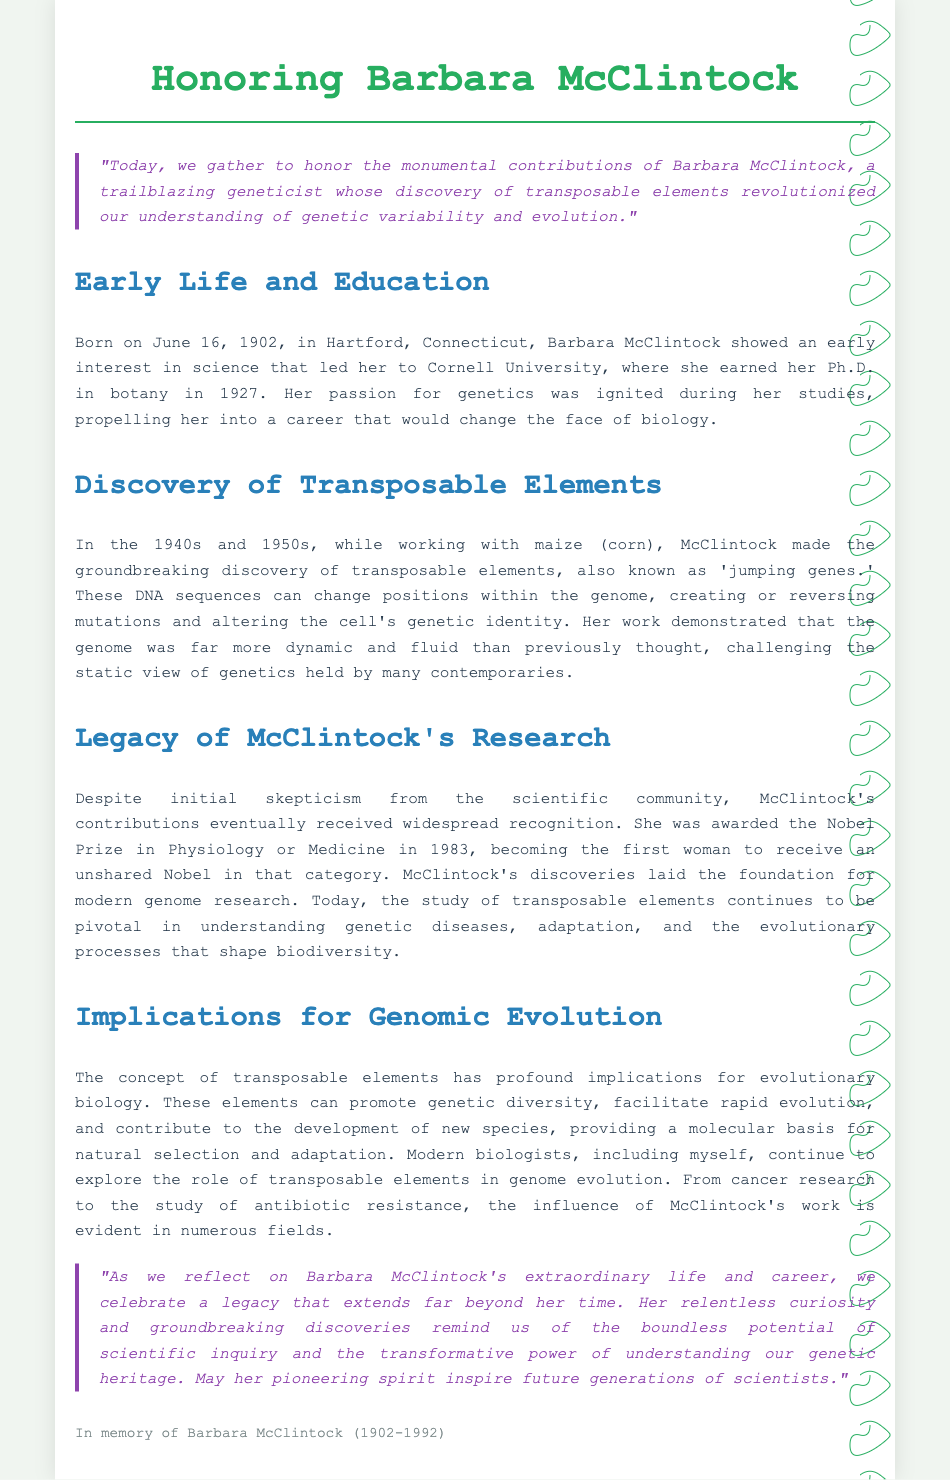what year was Barbara McClintock born? The document states that Barbara McClintock was born on June 16, 1902.
Answer: 1902 what did Barbara McClintock discover in the 1940s and 1950s? The discovery mentioned in the document is transposable elements, also known as 'jumping genes.'
Answer: transposable elements how many years did Barbara McClintock live? Barbara McClintock was born in 1902 and passed away in 1992, so she lived for 90 years.
Answer: 90 which university did Barbara McClintock attend for her Ph.D.? The document notes that she earned her Ph.D. at Cornell University.
Answer: Cornell University what was Barbara McClintock awarded in 1983? The document indicates that she was awarded the Nobel Prize in Physiology or Medicine in 1983.
Answer: Nobel Prize why were McClintock's contributions initially met with skepticism? The document mentions skepticism from the scientific community toward her discoveries of transposable elements.
Answer: skepticism how do transposable elements contribute to genetic variability? The document mentions that these elements can create or reverse mutations and alter the cell's genetic identity.
Answer: create or reverse mutations what impact is mentioned regarding McClintock's discoveries today? The document states that her discoveries are pivotal in understanding genetic diseases, adaptation, and evolutionary processes.
Answer: pivotal what is the significance of McClintock's legacy for future scientists? The document suggests that her pioneering spirit and discoveries inspire future generations of scientists.
Answer: inspire future generations 